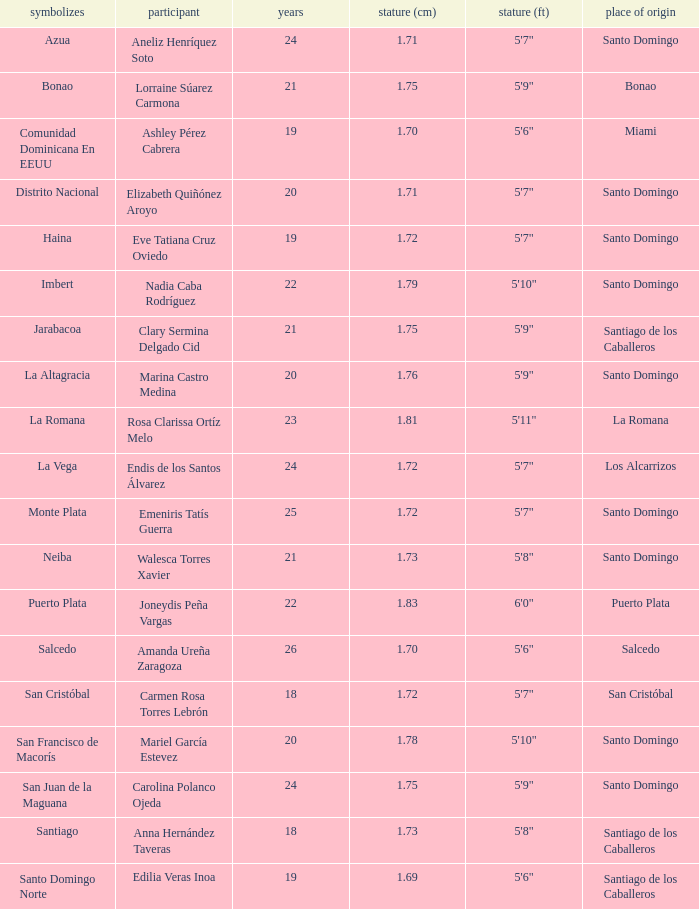Name the total number of represents for clary sermina delgado cid 1.0. 